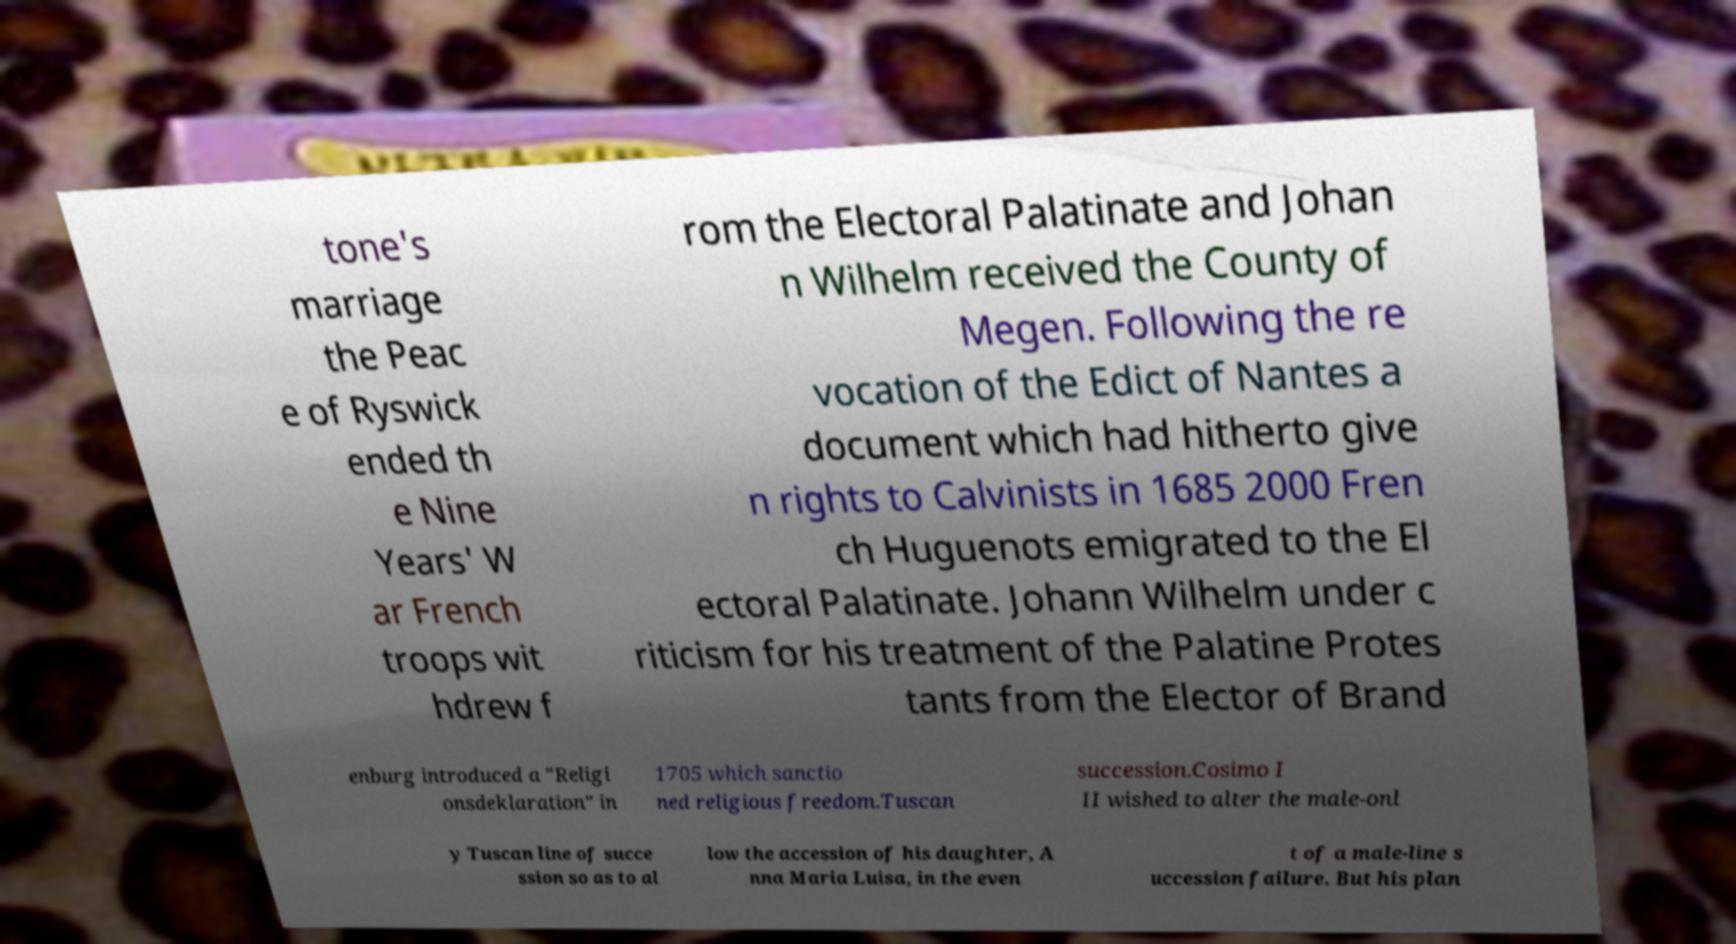Please identify and transcribe the text found in this image. tone's marriage the Peac e of Ryswick ended th e Nine Years' W ar French troops wit hdrew f rom the Electoral Palatinate and Johan n Wilhelm received the County of Megen. Following the re vocation of the Edict of Nantes a document which had hitherto give n rights to Calvinists in 1685 2000 Fren ch Huguenots emigrated to the El ectoral Palatinate. Johann Wilhelm under c riticism for his treatment of the Palatine Protes tants from the Elector of Brand enburg introduced a "Religi onsdeklaration" in 1705 which sanctio ned religious freedom.Tuscan succession.Cosimo I II wished to alter the male-onl y Tuscan line of succe ssion so as to al low the accession of his daughter, A nna Maria Luisa, in the even t of a male-line s uccession failure. But his plan 